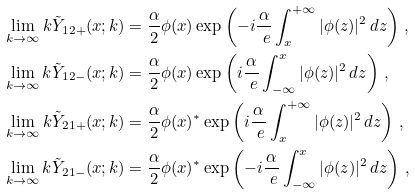<formula> <loc_0><loc_0><loc_500><loc_500>\lim _ { k \rightarrow \infty } k \tilde { Y } _ { 1 2 + } ( x ; k ) & = \frac { \alpha } { 2 } \phi ( x ) \exp \left ( - i \frac { \alpha } { \ e } \int _ { x } ^ { + \infty } | \phi ( z ) | ^ { 2 } \, d z \right ) \, , \\ \lim _ { k \rightarrow \infty } k \tilde { Y } _ { 1 2 - } ( x ; k ) & = \frac { \alpha } { 2 } \phi ( x ) \exp \left ( i \frac { \alpha } { \ e } \int _ { - \infty } ^ { x } | \phi ( z ) | ^ { 2 } \, d z \right ) \, , \\ \lim _ { k \rightarrow \infty } k \tilde { Y } _ { 2 1 + } ( x ; k ) & = \frac { \alpha } { 2 } \phi ( x ) ^ { * } \exp \left ( i \frac { \alpha } { \ e } \int _ { x } ^ { + \infty } | \phi ( z ) | ^ { 2 } \, d z \right ) \, , \\ \lim _ { k \rightarrow \infty } k \tilde { Y } _ { 2 1 - } ( x ; k ) & = \frac { \alpha } { 2 } \phi ( x ) ^ { * } \exp \left ( - i \frac { \alpha } { \ e } \int _ { - \infty } ^ { x } | \phi ( z ) | ^ { 2 } \, d z \right ) \, ,</formula> 